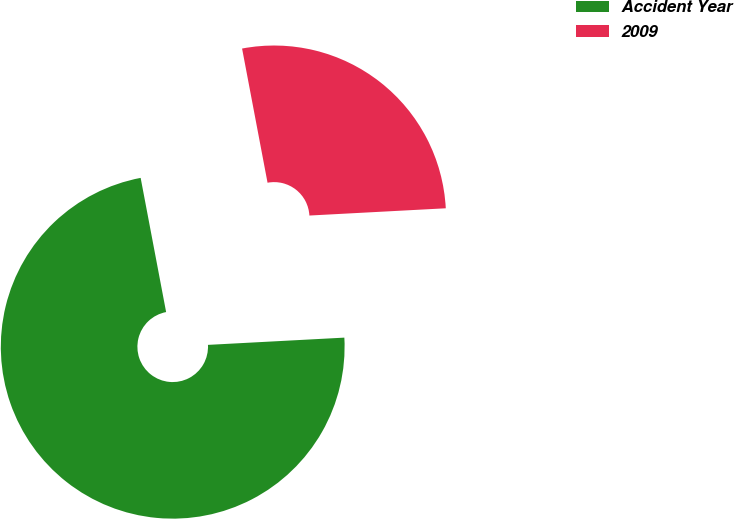Convert chart to OTSL. <chart><loc_0><loc_0><loc_500><loc_500><pie_chart><fcel>Accident Year<fcel>2009<nl><fcel>72.86%<fcel>27.14%<nl></chart> 